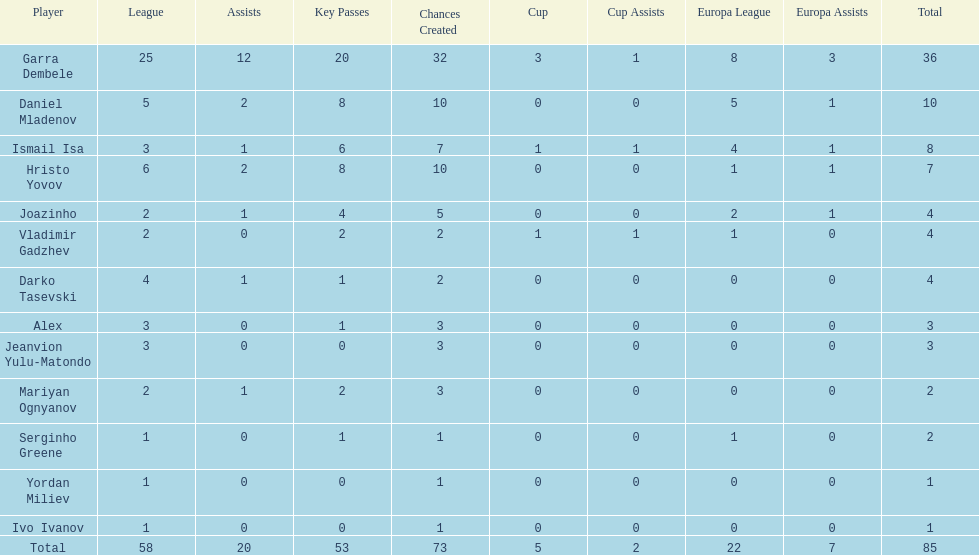Which players only scored one goal? Serginho Greene, Yordan Miliev, Ivo Ivanov. 